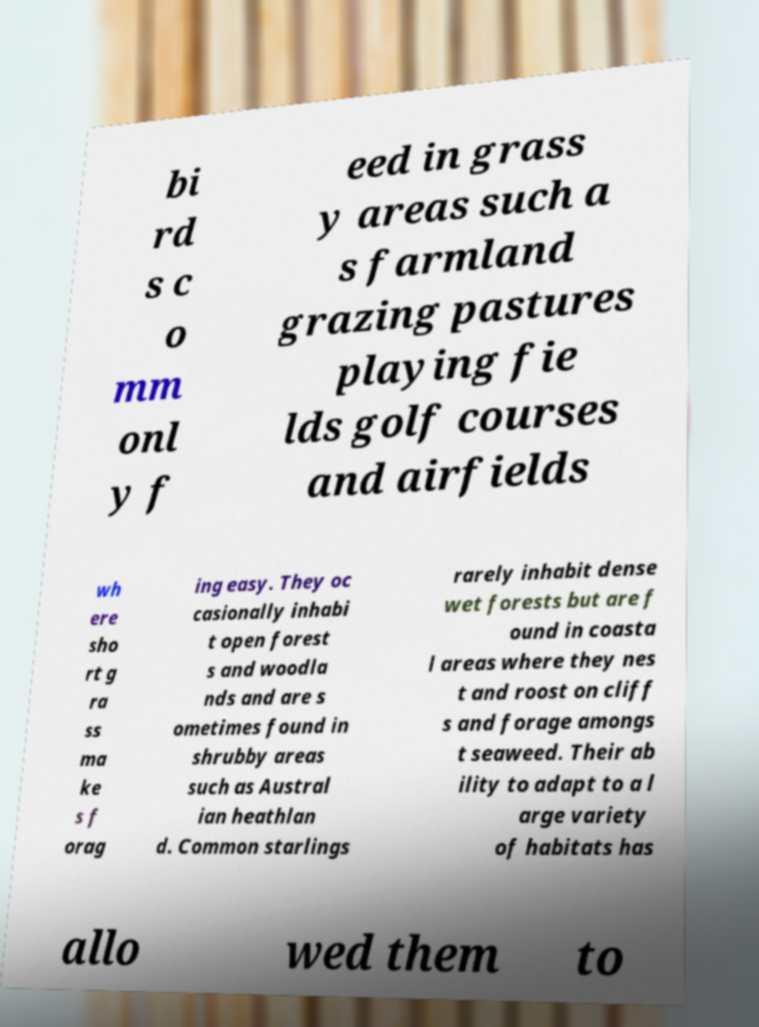Could you extract and type out the text from this image? bi rd s c o mm onl y f eed in grass y areas such a s farmland grazing pastures playing fie lds golf courses and airfields wh ere sho rt g ra ss ma ke s f orag ing easy. They oc casionally inhabi t open forest s and woodla nds and are s ometimes found in shrubby areas such as Austral ian heathlan d. Common starlings rarely inhabit dense wet forests but are f ound in coasta l areas where they nes t and roost on cliff s and forage amongs t seaweed. Their ab ility to adapt to a l arge variety of habitats has allo wed them to 